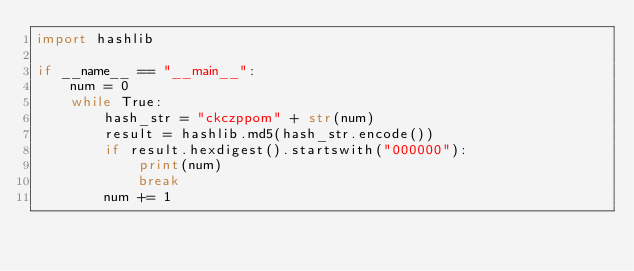Convert code to text. <code><loc_0><loc_0><loc_500><loc_500><_Python_>import hashlib

if __name__ == "__main__":
    num = 0
    while True:
        hash_str = "ckczppom" + str(num)
        result = hashlib.md5(hash_str.encode())
        if result.hexdigest().startswith("000000"):
            print(num)
            break
        num += 1
</code> 